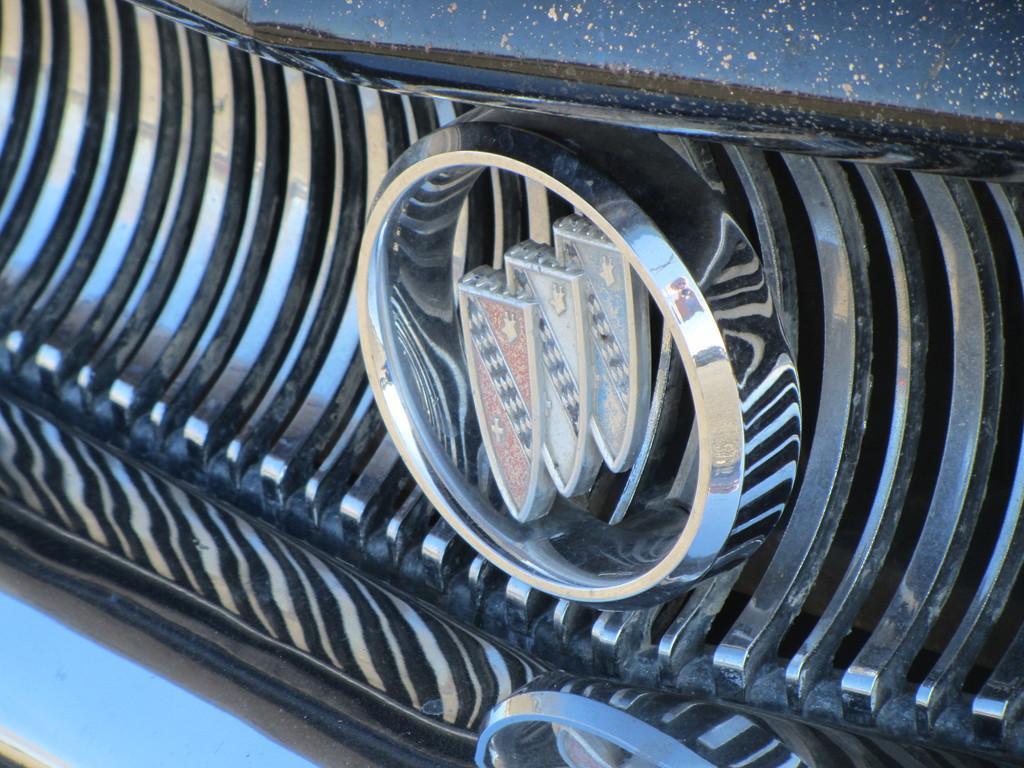How would you summarize this image in a sentence or two? In this picture we can see a logo. 